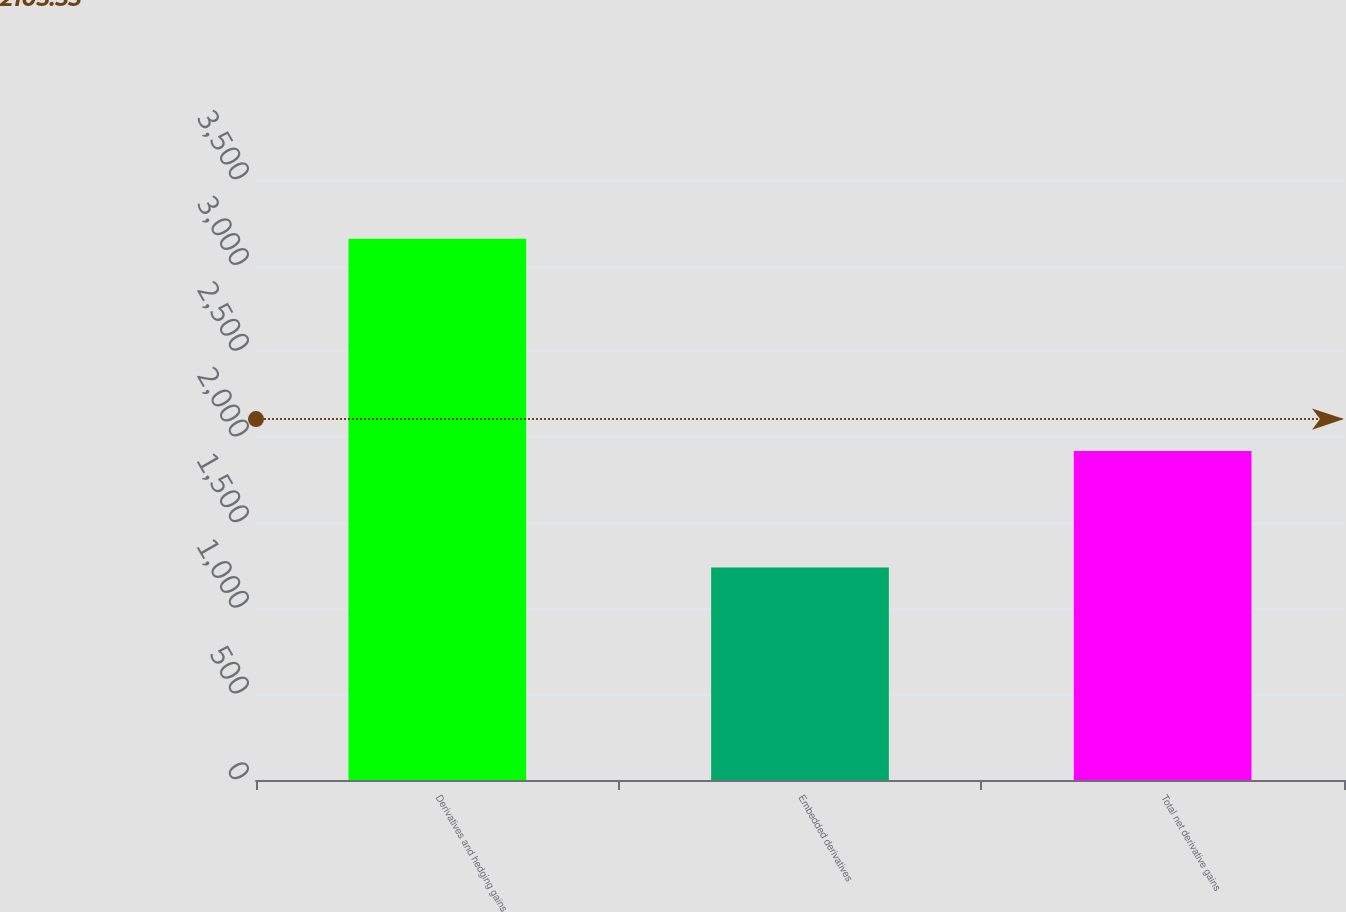<chart> <loc_0><loc_0><loc_500><loc_500><bar_chart><fcel>Derivatives and hedging gains<fcel>Embedded derivatives<fcel>Total net derivative gains<nl><fcel>3158<fcel>1239<fcel>1919<nl></chart> 